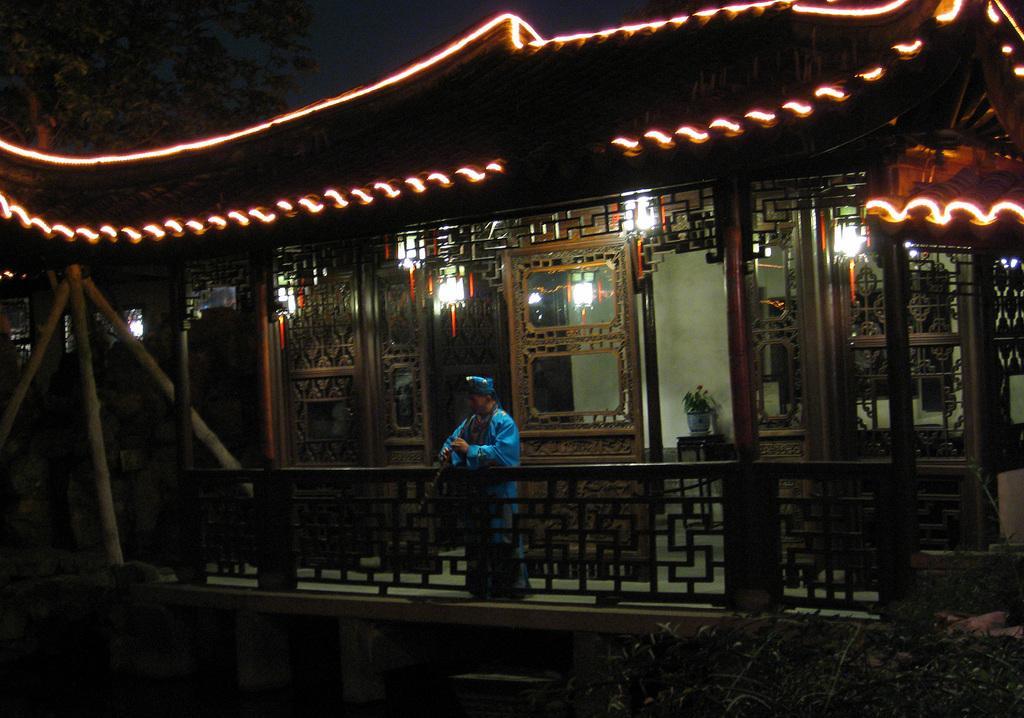In one or two sentences, can you explain what this image depicts? In the image we can see a person wearing clothes, this is a fence, building, glass doors, light, tree and a sky. These are the pillars and poles. 